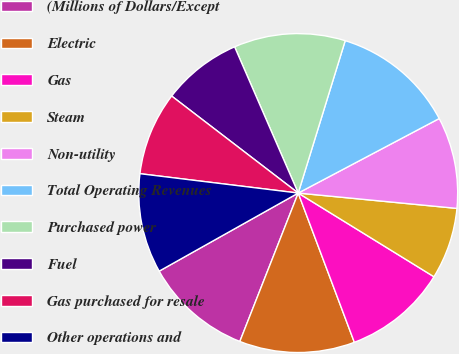Convert chart to OTSL. <chart><loc_0><loc_0><loc_500><loc_500><pie_chart><fcel>(Millions of Dollars/Except<fcel>Electric<fcel>Gas<fcel>Steam<fcel>Non-utility<fcel>Total Operating Revenues<fcel>Purchased power<fcel>Fuel<fcel>Gas purchased for resale<fcel>Other operations and<nl><fcel>10.89%<fcel>11.69%<fcel>10.48%<fcel>7.26%<fcel>9.27%<fcel>12.5%<fcel>11.29%<fcel>8.06%<fcel>8.47%<fcel>10.08%<nl></chart> 